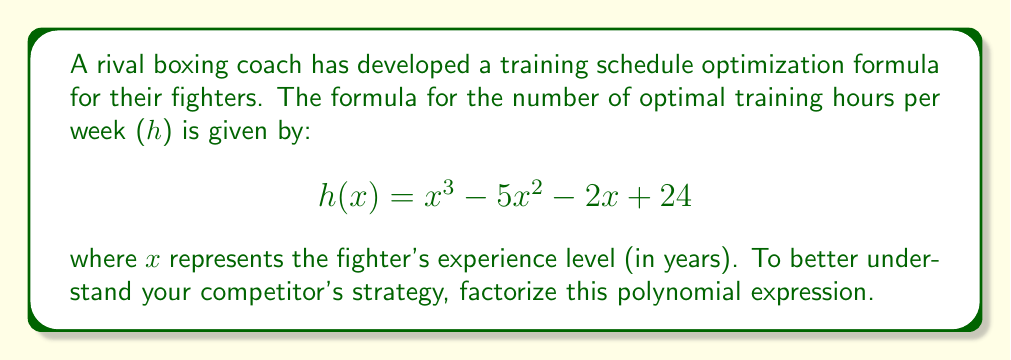Teach me how to tackle this problem. To factorize this cubic polynomial, we'll follow these steps:

1) First, we'll check if there are any rational roots using the rational root theorem. The possible rational roots are the factors of the constant term: ±1, ±2, ±3, ±4, ±6, ±8, ±12, ±24.

2) By testing these values, we find that x = 4 is a root of the polynomial.

3) Now we can factor out (x - 4):

   $$h(x) = (x - 4)(ax^2 + bx + c)$$

4) Expand this:

   $$x^3 + ax^2 - 4ax^2 + bx - 4bx + c - 4c = x^3 - 5x^2 - 2x + 24$$

5) Comparing coefficients:

   $$a = 1$$
   $$-4a + b = -5 \implies b = -1$$
   $$-4b + c = -2 \implies c = -6$$

6) So our factored form is:

   $$h(x) = (x - 4)(x^2 - x - 6)$$

7) The quadratic factor can be further factored:

   $$x^2 - x - 6 = (x - 3)(x + 2)$$

8) Therefore, the final factored form is:

   $$h(x) = (x - 4)(x - 3)(x + 2)$$
Answer: $$(x - 4)(x - 3)(x + 2)$$ 